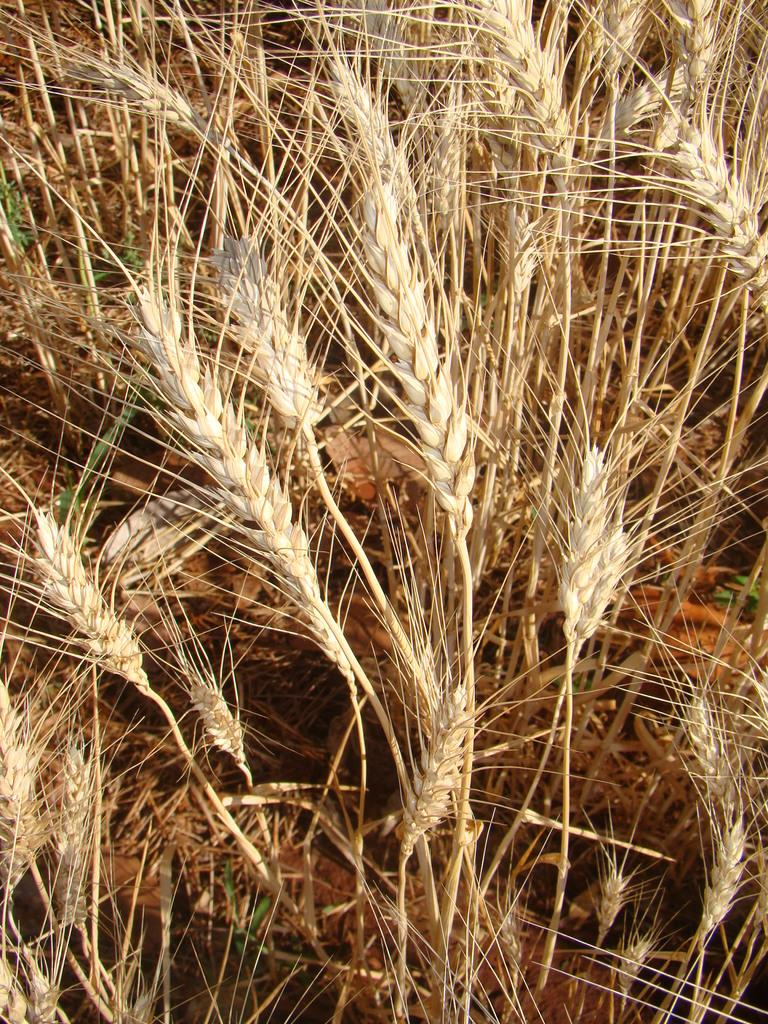What type of plants can be seen in the image? There are plants of wheat in the image. What type of bell can be seen hanging from the wheat plants in the image? There is no bell present in the image; it features plants of wheat only. What type of rice is growing alongside the wheat plants in the image? There is no rice present in the image; it only features plants of wheat. 